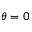<formula> <loc_0><loc_0><loc_500><loc_500>\theta = 0</formula> 